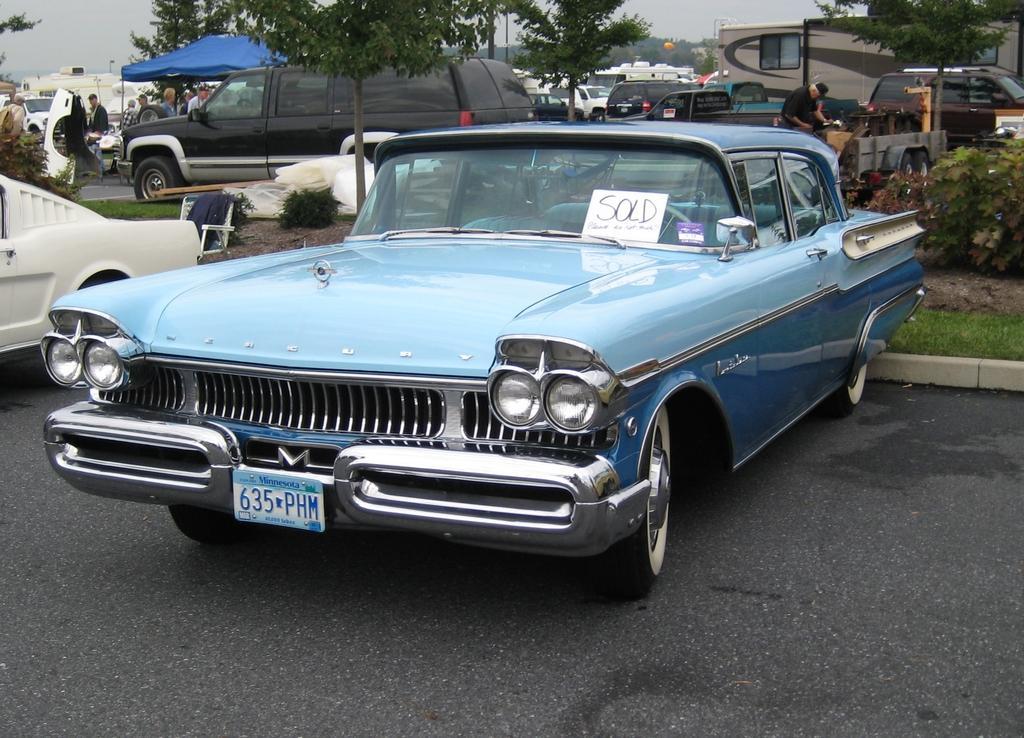Please provide a concise description of this image. In the center of the image we can see a vehicle with a number plate. And we can see the paper with some text on the front glass of a vehicle. In the background, we can see the sky, trees, plants, grass, vehicles, one tent, few people and a few other objects. 